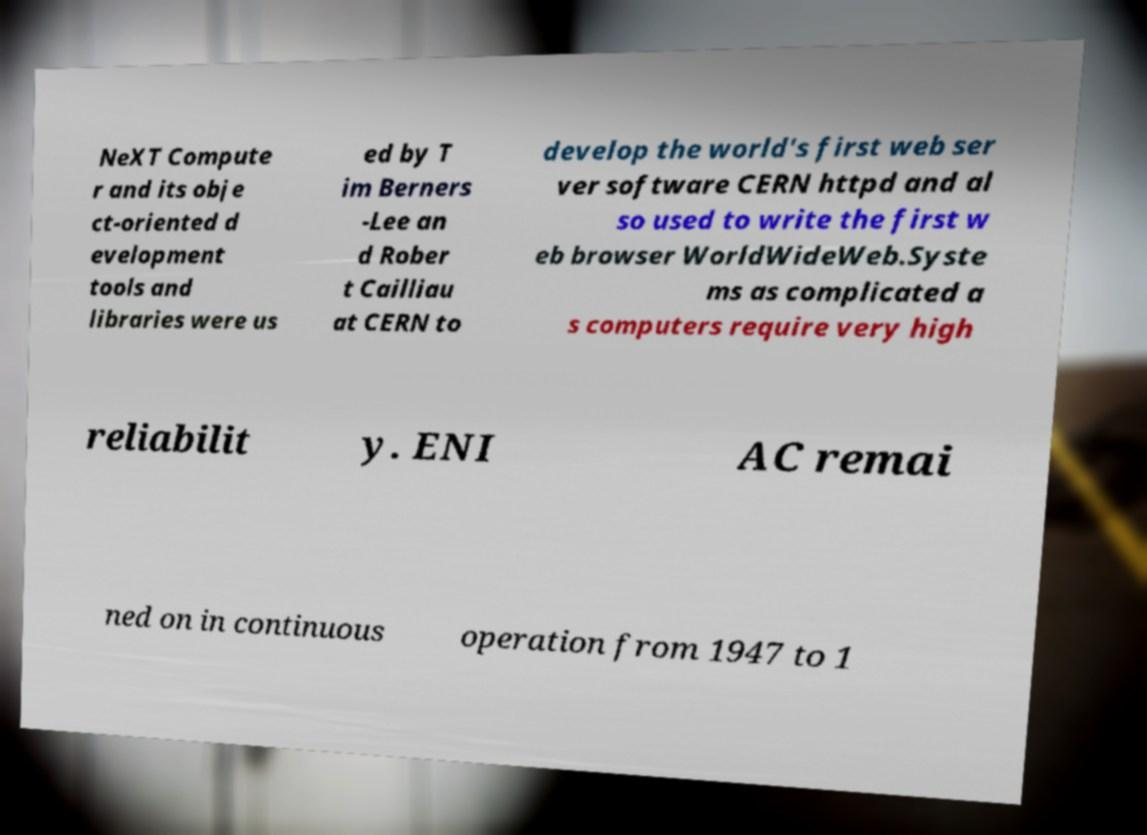Could you assist in decoding the text presented in this image and type it out clearly? NeXT Compute r and its obje ct-oriented d evelopment tools and libraries were us ed by T im Berners -Lee an d Rober t Cailliau at CERN to develop the world's first web ser ver software CERN httpd and al so used to write the first w eb browser WorldWideWeb.Syste ms as complicated a s computers require very high reliabilit y. ENI AC remai ned on in continuous operation from 1947 to 1 